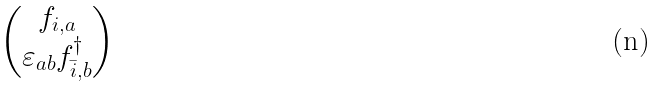<formula> <loc_0><loc_0><loc_500><loc_500>\begin{pmatrix} f _ { i , a } \\ \varepsilon _ { a b } f _ { \bar { i } , b } ^ { \dagger } \end{pmatrix}</formula> 